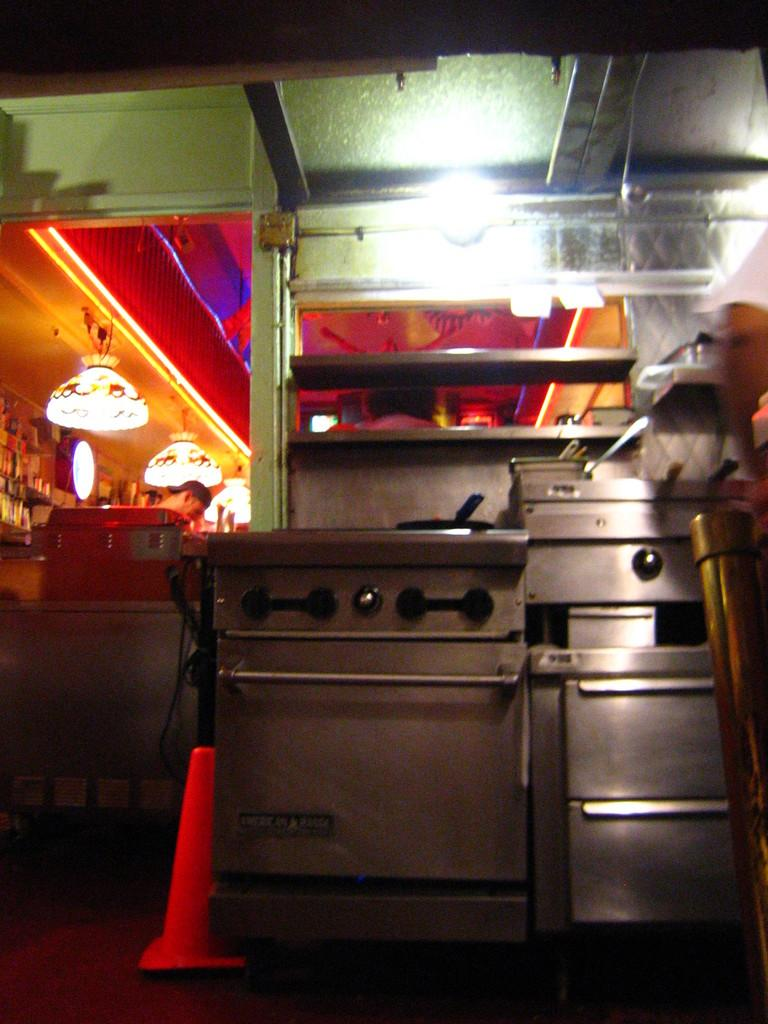Who or what is present in the image? There is a person in the image. What objects can be seen on a table in the image? There are boxes on a table in the image. What is visible on top in the image? There are lights visible on top in the image. What cooking utensil is present in the image? There is a pan on a surface in the image. What type of voice can be heard coming from the pan in the image? There is no voice coming from the pan in the image, as it is a cooking utensil and not capable of producing sound. 